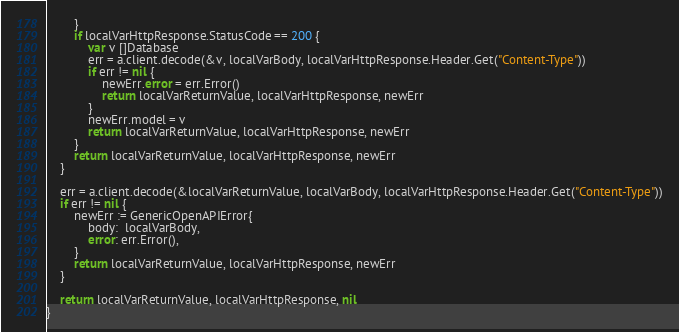Convert code to text. <code><loc_0><loc_0><loc_500><loc_500><_Go_>		}
		if localVarHttpResponse.StatusCode == 200 {
			var v []Database
			err = a.client.decode(&v, localVarBody, localVarHttpResponse.Header.Get("Content-Type"))
			if err != nil {
				newErr.error = err.Error()
				return localVarReturnValue, localVarHttpResponse, newErr
			}
			newErr.model = v
			return localVarReturnValue, localVarHttpResponse, newErr
		}
		return localVarReturnValue, localVarHttpResponse, newErr
	}

	err = a.client.decode(&localVarReturnValue, localVarBody, localVarHttpResponse.Header.Get("Content-Type"))
	if err != nil {
		newErr := GenericOpenAPIError{
			body:  localVarBody,
			error: err.Error(),
		}
		return localVarReturnValue, localVarHttpResponse, newErr
	}

	return localVarReturnValue, localVarHttpResponse, nil
}
</code> 